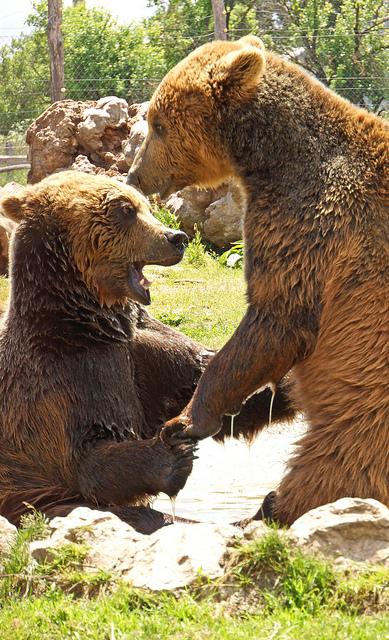Is it a sunny day?
Short answer required. Yes. Are the bears in the wild?
Write a very short answer. No. How many bears do you see?
Concise answer only. 2. 